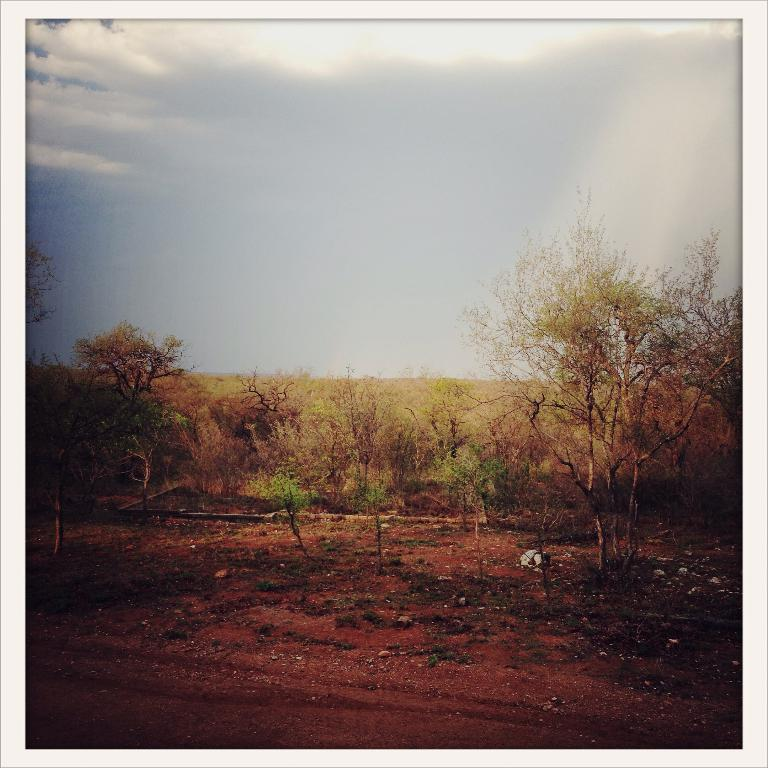What type of vegetation can be seen in the image? There is grass in the image. What else is present on the ground in the image? There are stones on the ground in the image. What other natural elements can be seen in the image? There are trees in the image. What is visible in the background of the image? The sky is visible in the background of the image. What can be observed in the sky in the image? Clouds are present in the sky. How many weeks can be seen in the image? There are no weeks present in the image; it is a visual representation of a natural environment. 